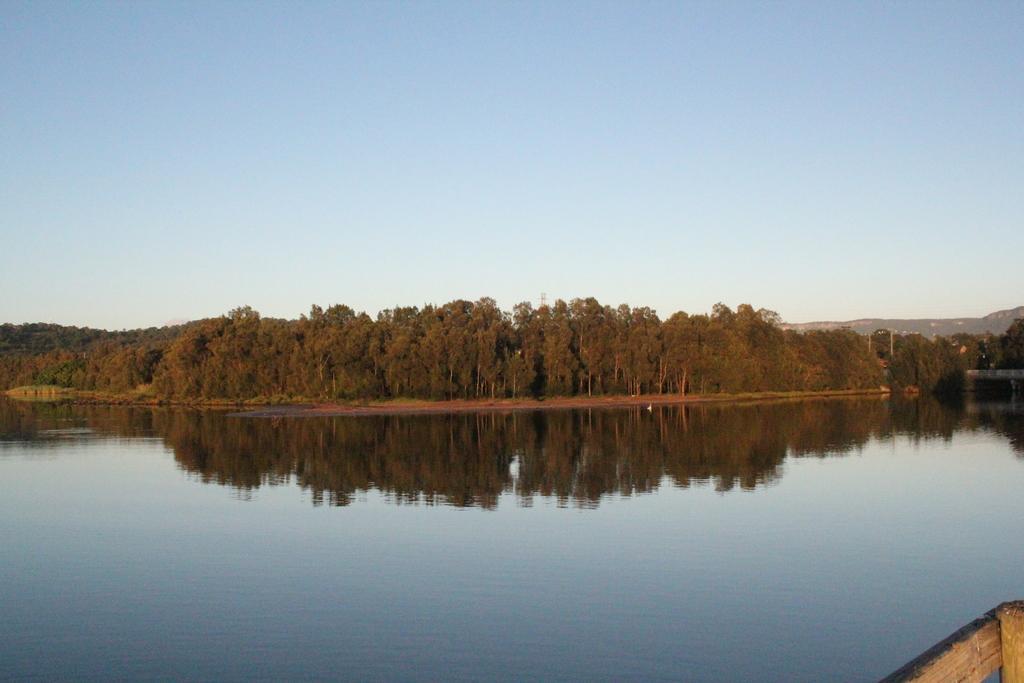In one or two sentences, can you explain what this image depicts? In the background we can see the sky and a hill is visible. In this picture we can see trees, water. We can see the reflection on the water. In the bottom right corner of the picture we can see wooden object. 